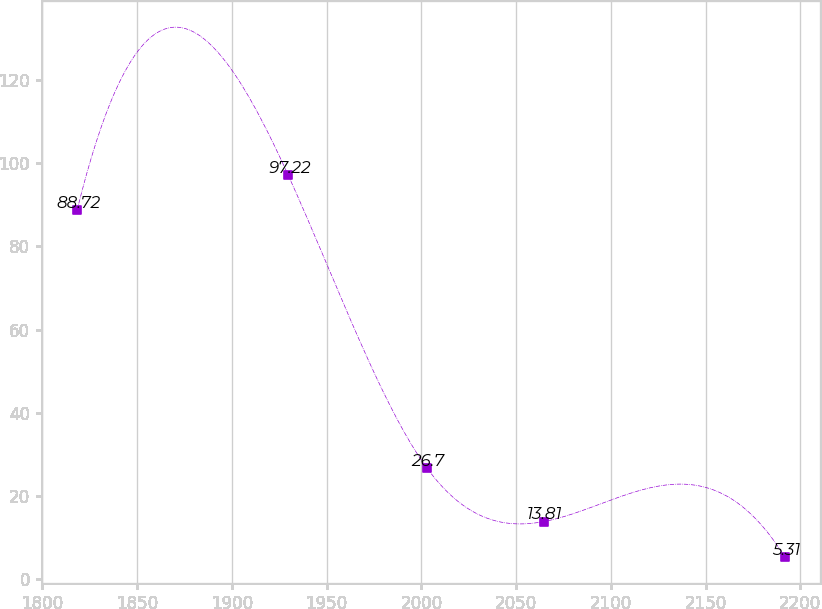Convert chart to OTSL. <chart><loc_0><loc_0><loc_500><loc_500><line_chart><ecel><fcel>Unnamed: 1<nl><fcel>1818.27<fcel>88.72<nl><fcel>1929.66<fcel>97.22<nl><fcel>2002.95<fcel>26.7<nl><fcel>2064.53<fcel>13.81<nl><fcel>2191.85<fcel>5.31<nl></chart> 